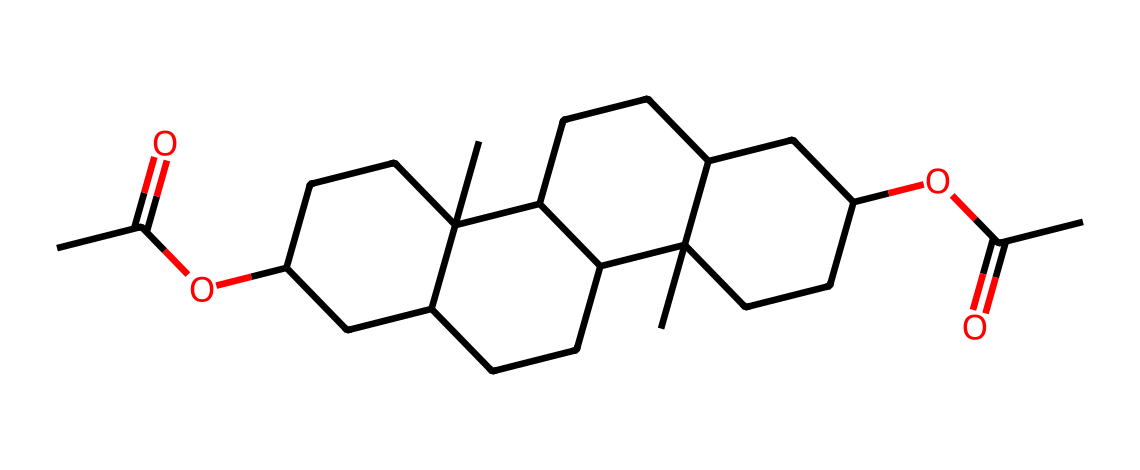What functional groups are present in this chemical? By analyzing the SMILES representation, we can identify the presence of carbonyl groups (indicated by C=O) and ester groups (indicated by -O-C=O). These groups suggest that the chemical contains both ketone characters through the carbonyls and ethers through the esters.
Answer: carbonyl and ester How many carbon atoms are there in the structure? The SMILES notation shows multiple 'C's, where each 'C' typically represents a carbon atom. By counting all individual carbon elements in the notation, we arrive at the total number, which is 25.
Answer: 25 Is this compound a polar or non-polar molecule? The presence of multiple functional groups, particularly esters and a few carbonyls, gives it some polar character; however, the long hydrocarbon chains dominate in non-polar characteristics, rendering the entire compound significantly non-polar.
Answer: non-polar What molecular feature indicates that this is a non-electrolyte? Non-electrolytes typically do not dissociate into ions in solution. The presence of esters and long carbon chains without ionic bonds or highly electronegative atoms suggests it will not dissociate in an aqueous environment.
Answer: absence of ions What is the overall shape of this molecule likely to be? Given the presence of multiple cycloalkane rings and branched chains in the SMILES depiction, the molecule will likely have a three-dimensional shape that is bulkier due to steric hindrance, resembling a complex hydrocarbon framework.
Answer: bulky and complex How many rings are present in the chemical structure? Examining the carbon framework, we can count the number of cyclic structures indicated by the symbols within the SMILES. These indicate there are four distinct cyclic structures formed in this compound.
Answer: 4 